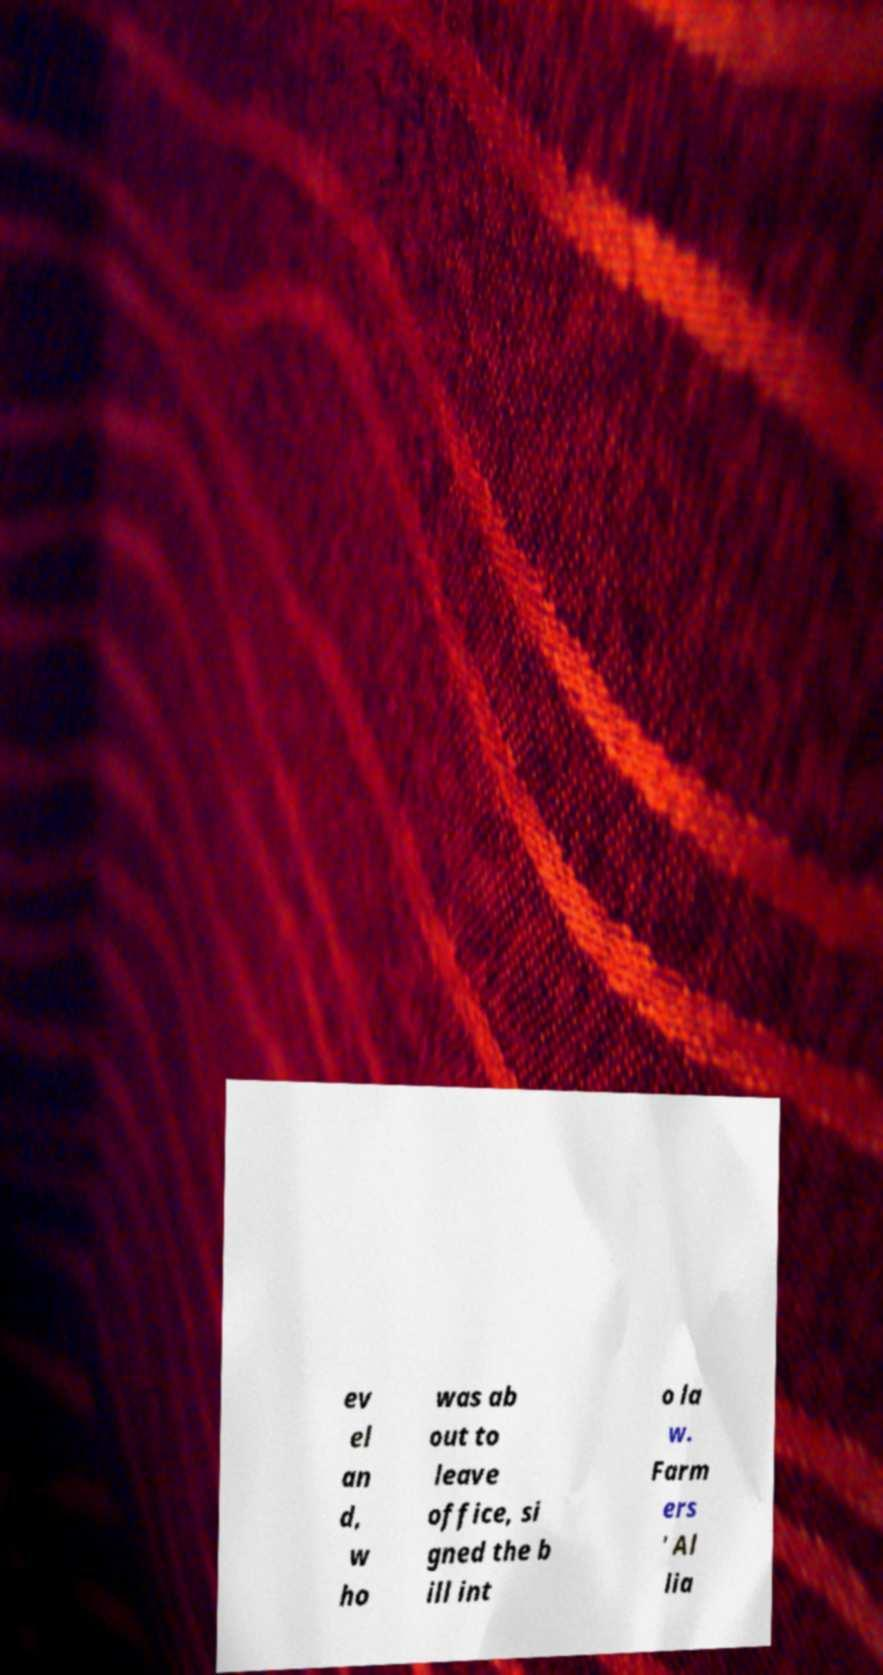Please identify and transcribe the text found in this image. ev el an d, w ho was ab out to leave office, si gned the b ill int o la w. Farm ers ' Al lia 